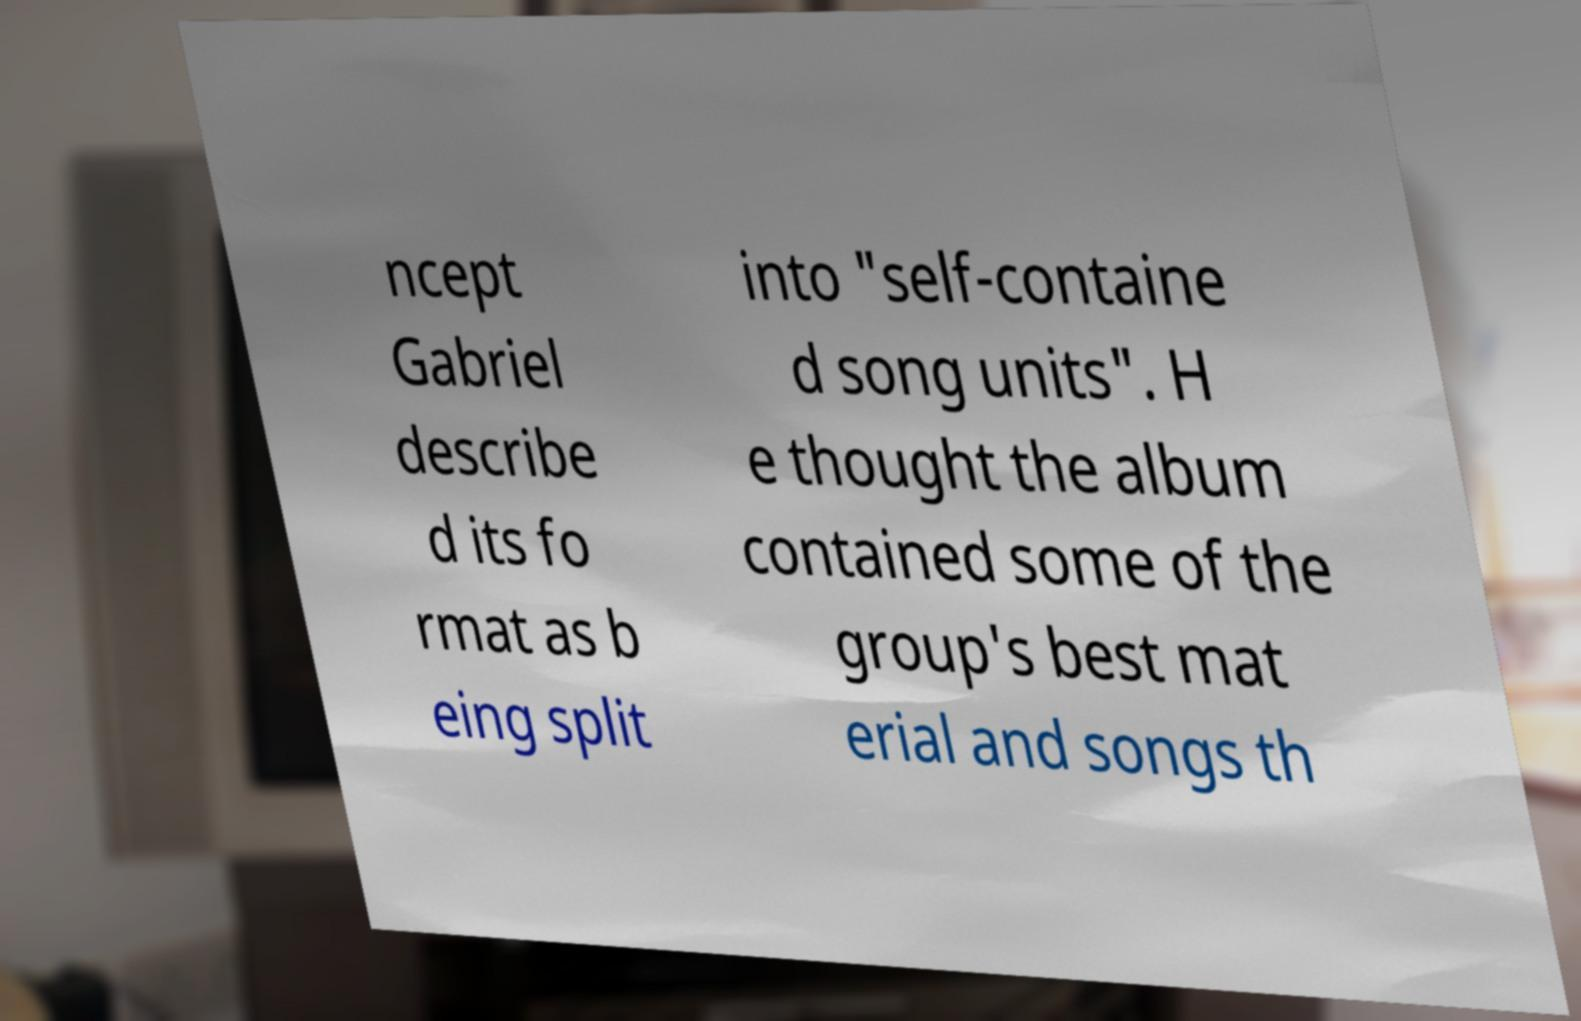For documentation purposes, I need the text within this image transcribed. Could you provide that? ncept Gabriel describe d its fo rmat as b eing split into "self-containe d song units". H e thought the album contained some of the group's best mat erial and songs th 